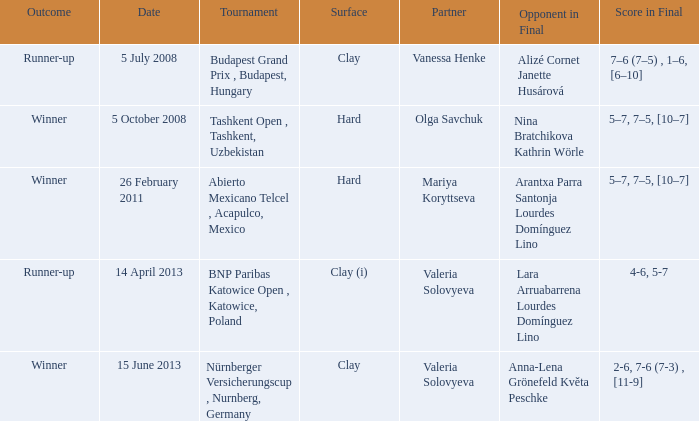Name the outcome that had an opponent in final of nina bratchikova kathrin wörle Winner. 